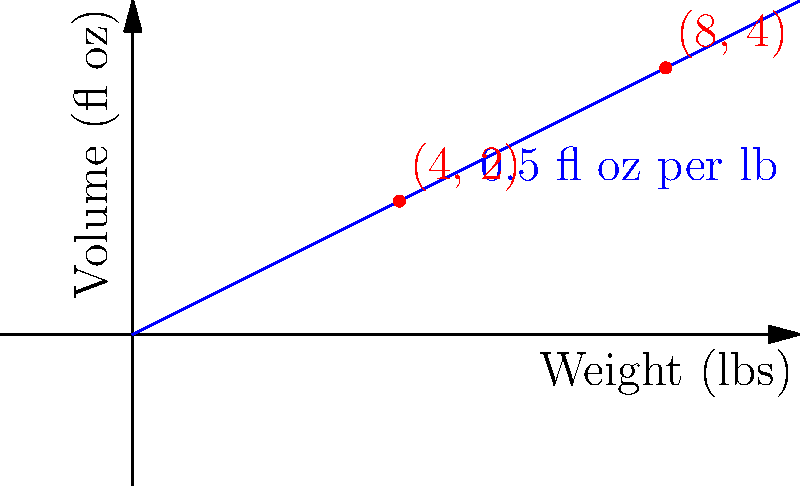Using the volume-to-weight ratio diagram for marinade, how many fluid ounces of marinade would you need for a 6-pound brisket? To determine the amount of marinade needed for a 6-pound brisket, we'll follow these steps:

1. Analyze the diagram:
   - The x-axis represents the weight of the meat in pounds.
   - The y-axis represents the volume of marinade in fluid ounces.
   - The blue line shows the relationship between weight and volume.

2. Identify the ratio:
   - The diagram is labeled "0.5 fl oz per lb", indicating the ratio.
   - This means for every 1 pound of meat, we need 0.5 fluid ounces of marinade.

3. Calculate the marinade needed:
   - For a 6-pound brisket, we multiply the weight by the ratio:
   - $6 \text{ lbs} \times 0.5 \text{ fl oz/lb} = 3 \text{ fl oz}$

4. Verify using the graph:
   - We can visualize this on the graph by finding the point where x = 6.
   - The corresponding y-value would be 3, confirming our calculation.

Therefore, for a 6-pound brisket, you would need 3 fluid ounces of marinade.
Answer: 3 fl oz 